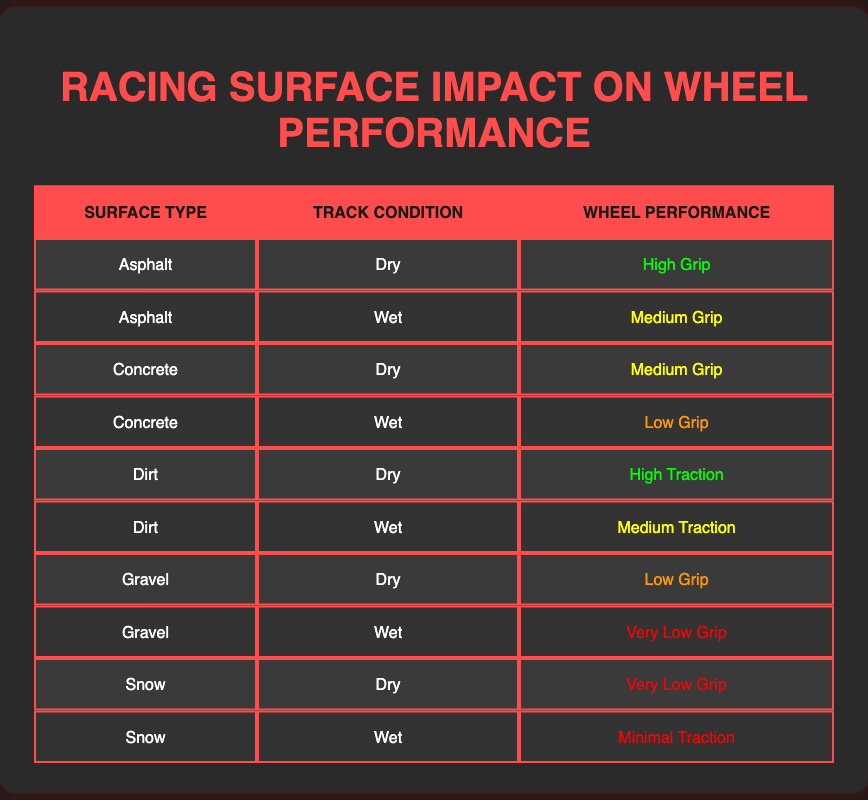What wheel performance is expected on dry asphalt? The table shows that under dry conditions on asphalt, the wheel performance is categorized as "High Grip."
Answer: High Grip Is the wheel performance on wet concrete better than on wet gravel? Comparing wet conditions, the performance on concrete is "Low Grip," while on gravel it is "Very Low Grip," indicating wet concrete has better performance than wet gravel.
Answer: Yes What are the performances categorized under dry conditions across all surfaces? Under dry conditions, the performances are as follows: Asphalt - High Grip, Concrete - Medium Grip, Dirt - High Traction, Gravel - Low Grip, Snow - Very Low Grip.
Answer: High Grip, Medium Grip, High Traction, Low Grip, Very Low Grip How many types of wheel performance are categorized as low on wet surfaces? The table lists "Low Grip" for wet concrete, "Very Low Grip" for wet gravel, and "Minimal Traction" for wet snow, which gives us a total of three distinct categories.
Answer: 3 Is there any surface type where the performance is the same for both dry and wet conditions? Asphalt records High Grip in dry and Medium Grip in wet, Concrete sees Medium Grip in dry and Low Grip in wet, Dirt performs High Traction in dry and Medium Traction in wet, Gravel drops from Low Grip to Very Low Grip, and Snow is Very Low Grip in dry to Minimal Traction in wet, so there are no surfaces with the same performance in both conditions.
Answer: No What is the difference in wheel performance between dry dirt and wet dirt conditions? Dry dirt yields "High Traction" while wet dirt results in "Medium Traction," indicating that the performance decreases; thus, the difference is from High Traction to Medium Traction in terms of grip strength.
Answer: High Traction to Medium Traction Which surface type has the least wheel performance in wet conditions? The table indicates that both wet gravel and wet snow have the lowest performances, with wet gravel at "Very Low Grip" and wet snow at "Minimal Traction," but Very Low Grip in gravel represents the lowest performance rating.
Answer: Wet Gravel How would you rank the wheel performances on dry conditions from highest to lowest? The performances from highest to lowest in dry conditions are: 1) High Grip (Asphalt), 2) High Traction (Dirt), 3) Medium Grip (Concrete), 4) Low Grip (Gravel), 5) Very Low Grip (Snow).
Answer: High Grip, High Traction, Medium Grip, Low Grip, Very Low Grip Do all surfaces provide better wheel performance in dry conditions compared to their wet counterparts? By comparing wet and dry conditions, Asphalt and Dirt show improved performance in dry conditions, whereas Concrete and Gravel lose performance when wet, and Snow also performs worse wet than dry; thus, not all surfaces perform better dry.
Answer: No 